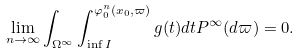Convert formula to latex. <formula><loc_0><loc_0><loc_500><loc_500>\lim _ { n \to \infty } \int _ { \Omega ^ { \infty } } \int _ { \inf I } ^ { \varphi _ { 0 } ^ { n } ( x _ { 0 } , \varpi ) } g ( t ) d t P ^ { \infty } ( d \varpi ) = 0 .</formula> 